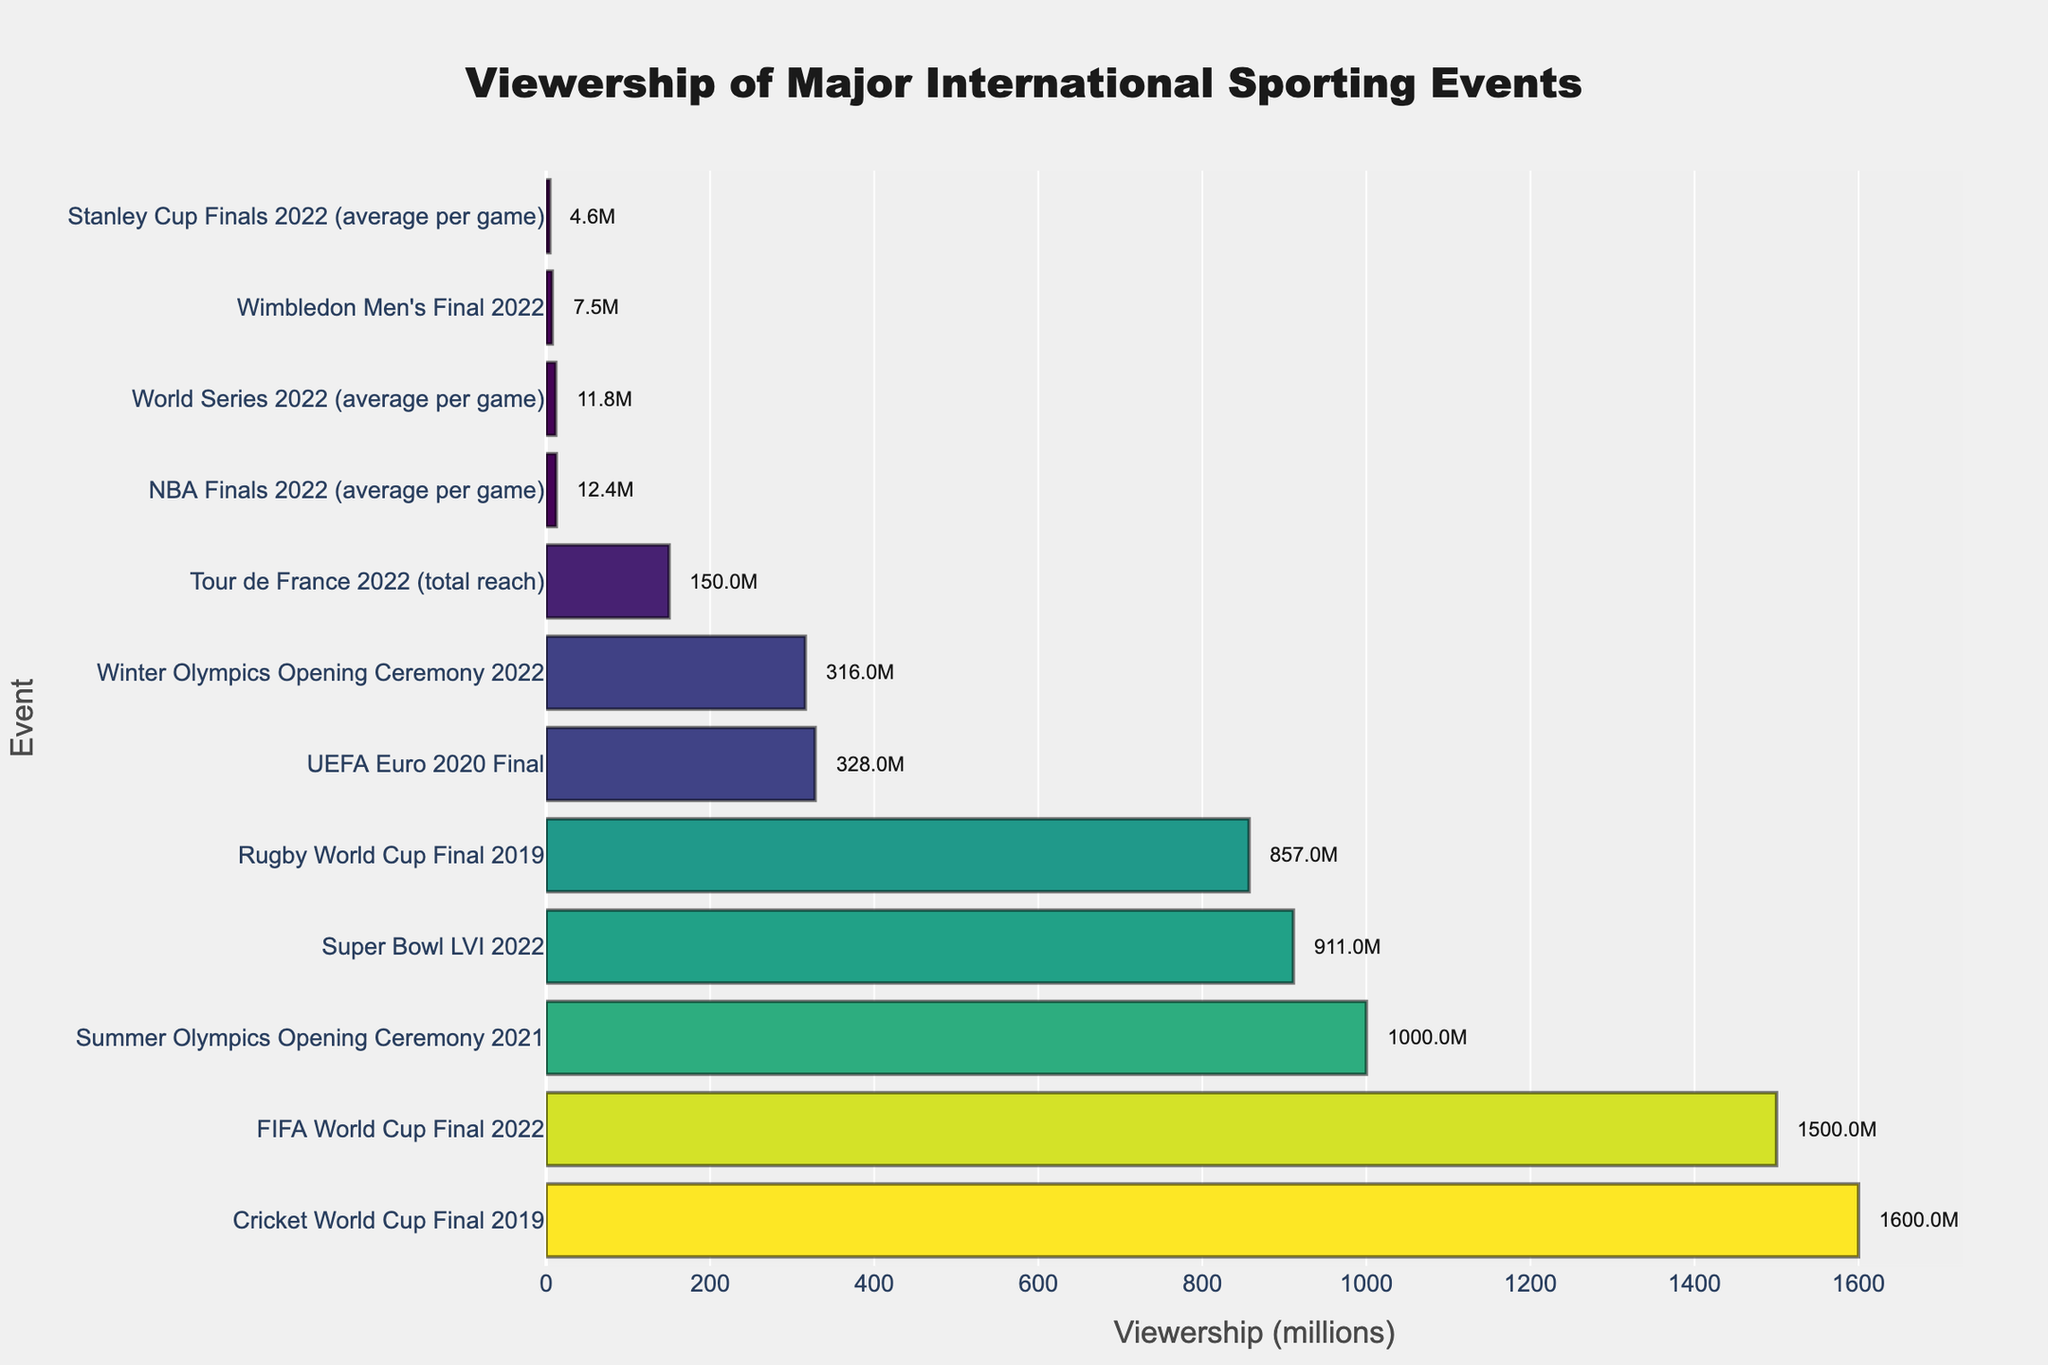Which event had the highest viewership? The bar chart shows that the Cricket World Cup Final 2019 has the longest bar, indicating it has the highest viewership.
Answer: Cricket World Cup Final 2019 How much higher was the viewership for the FIFA World Cup Final 2022 compared to the Super Bowl LVI 2022? The viewership for the FIFA World Cup Final 2022 is 1500 million, and for the Super Bowl LVI 2022 is 911 million. The difference is 1500 - 911 = 589 million.
Answer: 589 million Which event had the lowest viewership? The bar representing NBA Finals 2022 (average per game) is the shortest on the chart, indicating it had the lowest viewership.
Answer: NBA Finals 2022 (average per game) Among the UEFA Euro 2020 Final and Winter Olympics Opening Ceremony 2022, which one had higher viewership and by how much? The viewership for the UEFA Euro 2020 Final is 328 million and for the Winter Olympics Opening Ceremony 2022 is 316 million. The difference is 328 - 316 = 12 million.
Answer: UEFA Euro 2020 Final by 12 million Rank the top 3 events based on their viewership numbers. From the bar lengths, the top 3 events by viewership are: 1. Cricket World Cup Final 2019 (1600 million), 2. FIFA World Cup Final 2022 (1500 million), 3. Summer Olympics Opening Ceremony 2021 (1000 million).
Answer: 1. Cricket World Cup Final 2019, 2. FIFA World Cup Final 2022, 3. Summer Olympics Opening Ceremony 2021 What is the combined viewership of the Winter Olympics Opening Ceremony 2022 and the Stanley Cup Finals 2022 (average per game)? The viewership for the Winter Olympics Opening Ceremony 2022 is 316 million and for the Stanley Cup Finals 2022 (average per game) is 4.6 million. The combined viewership is 316 + 4.6 = 320.6 million.
Answer: 320.6 million Is the viewership of the UEFA Euro 2020 Final closer to the Winter Olympics Opening Ceremony 2022 or the Super Bowl LVI 2022? The viewership for the UEFA Euro 2020 Final is 328 million, Winter Olympics Opening Ceremony is 316 million, and Super Bowl LVI is 911 million. The difference with Winter Olympics is 328 - 316 = 12 million, and with the Super Bowl is 911 - 328 = 583 million. It is closer to Winter Olympics.
Answer: Winter Olympics Opening Ceremony 2022 Does the length of the bar representing the Summer Olympics Opening Ceremony 2021 or the Super Bowl LVI 2022 appear longer? The bar representing the Summer Olympics Opening Ceremony 2021 is visually longer than the bar representing the Super Bowl LVI 2022, indicating higher viewership.
Answer: Summer Olympics Opening Ceremony 2021 How does the total reach of the Tour de France 2022 compare to the Wimbledon Men's Final 2022 in terms of viewership? The viewership of the Tour de France 2022 is 150 million and Wimbledon Men's Final 2022 is 7.5 million. The Tour de France 2022 has significantly higher viewership.
Answer: Tour de France 2022 What's the difference in viewership between the Rugby World Cup Final 2019 and the NBA Finals 2022 (average per game)? The viewership for the Rugby World Cup Final 2019 is 857 million and for the NBA Finals 2022 (average per game) is 12.4 million. The difference is 857 - 12.4 = 844.6 million.
Answer: 844.6 million 